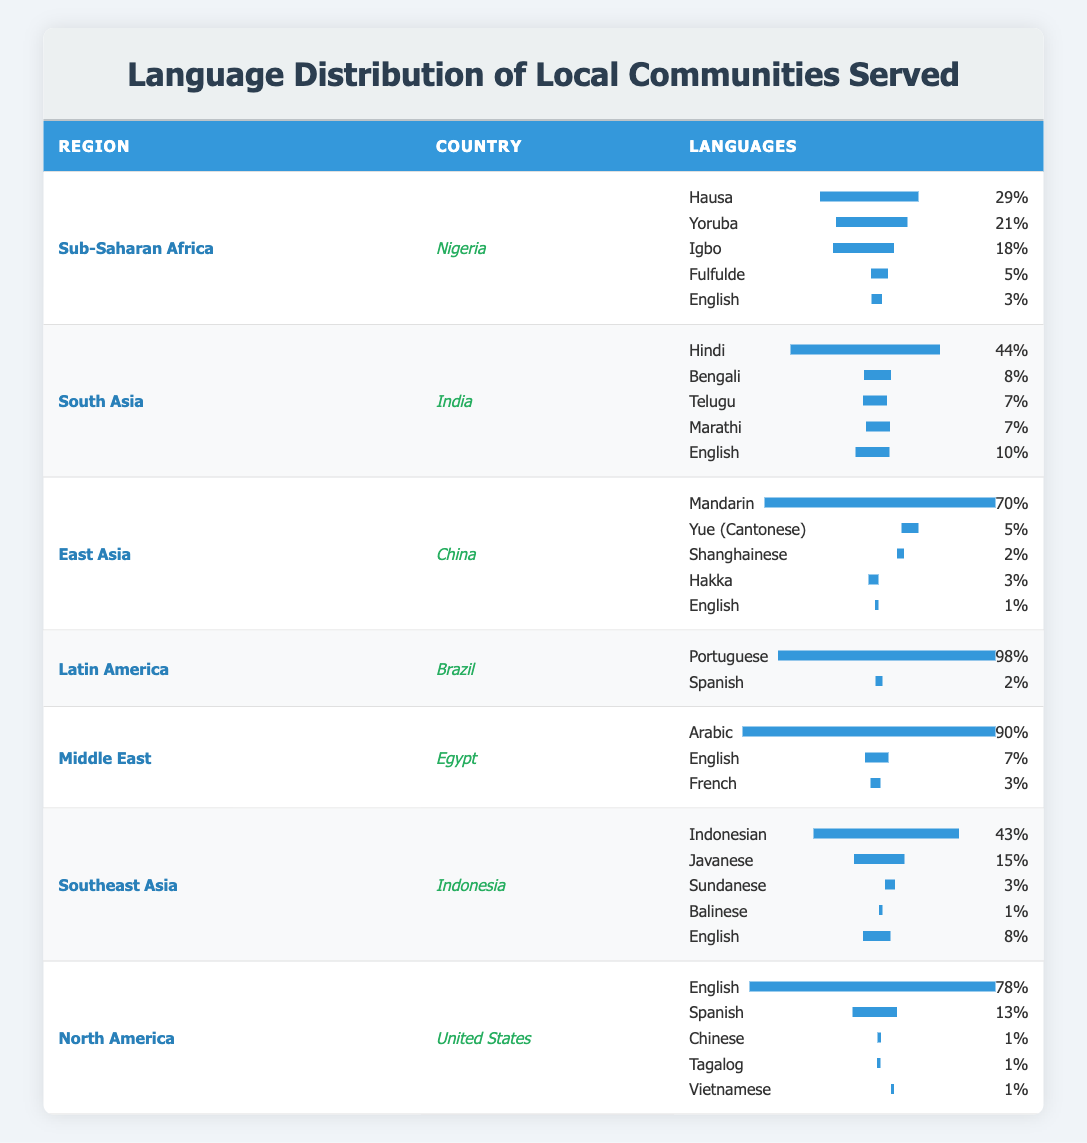What is the most spoken language in Nigeria? The table shows that in Nigeria, the language with the highest percentage is Hausa at 29%.
Answer: Hausa Which country in South Asia has the highest percentage of English speakers? The table displays that in India, English has a percentage of 10%, which is the only country listed in South Asia. Thus, it is the highest by default.
Answer: India Is Arabic the most spoken language in Egypt? According to the table, Arabic has a percentage of 90%, which is higher than the other languages listed for Egypt, confirming it as the most spoken language.
Answer: Yes What percentage of speakers in China speak Mandarin? The table indicates that in China, Mandarin has a significant percentage of 70%, making it the language with the highest proportion.
Answer: 70% How many languages are listed for Brazil, and what is the percentage of Portuguese speakers? For Brazil, there are two languages listed: Portuguese at 98% and Spanish at 2%. The main language spoken is Portuguese, which has the highest percentage of 98%.
Answer: 2 languages; Portuguese 98% Which region has the lowest percentage of speakers for the first language listed? The region with the lowest percentage for the first language (Mandarin in China) is the Middle East where the first language (Arabic) has a percentage of 90%, and the first language in the Southeast Asia region (Indonesian) has a percentage of 43%. Therefore, Southeast Asia has the lowest first language percentage.
Answer: Southeast Asia What is the total percentage of English speakers in North America? In the table, the percentage of English speakers in the United States is stated as 78%, with no other countries listed in the North America section that have English speakers. Thus the total is 78%.
Answer: 78% Which language has the second highest percentage in Nigeria? The second highest percentage language in Nigeria is Yoruba with 21%, following Hausa, which is the highest.
Answer: Yoruba What language is spoken by the smallest percentage in China? The smallest percentage language in China is Chinese with only 1% of speakers.
Answer: Chinese 